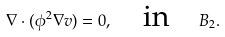Convert formula to latex. <formula><loc_0><loc_0><loc_500><loc_500>\nabla \cdot ( \phi ^ { 2 } \nabla v ) = 0 , \quad \text {in} \quad B _ { 2 } .</formula> 